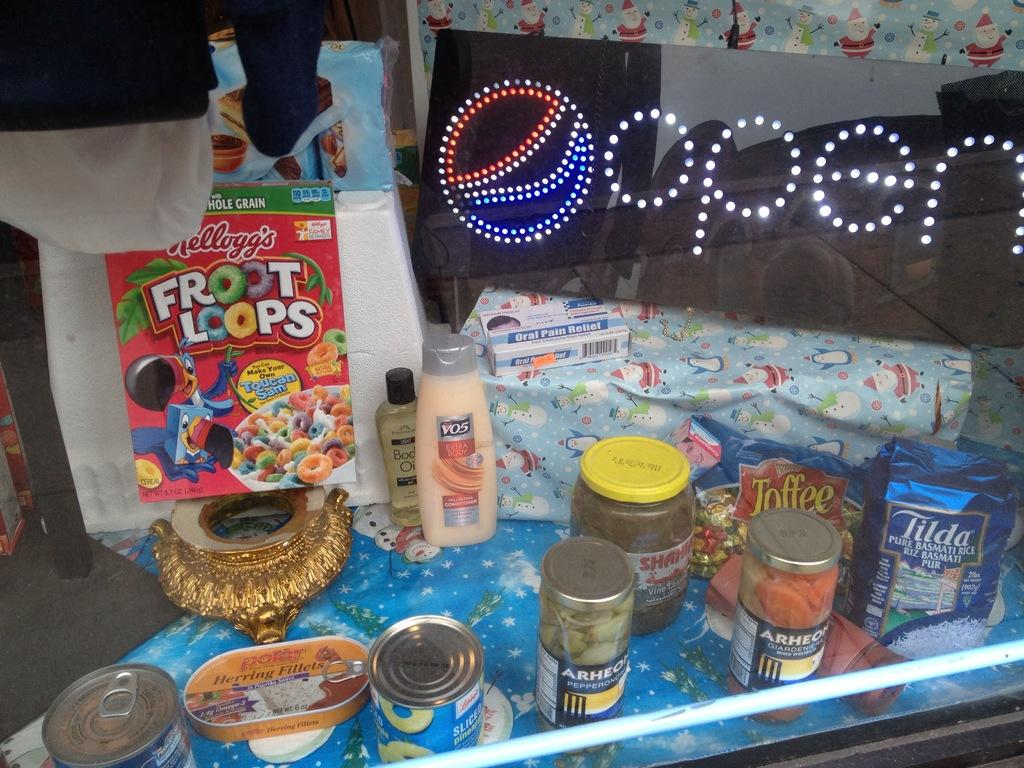What type of objects can be seen in the image? There are boxes, bottles, a gift wrapper, and other objects in the image. Can you describe the purpose of the gift wrapper? The gift wrapper is likely used for wrapping presents or gifts. What is the name board used for in the image? The name board is used to display a name or label for the objects or location. What is visible behind the objects in the image? There is a wall visible behind the objects in the image. What type of education is being distributed in the image? There is no indication of education or distribution in the image; it primarily features objects such as boxes, bottles, and a gift wrapper. Is there a quilt visible in the image? No, there is no quilt present in the image. 